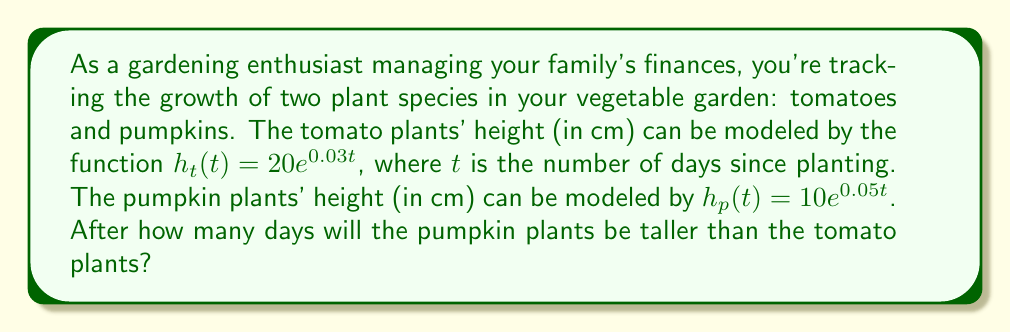Provide a solution to this math problem. To solve this problem, we need to find the point where the heights of the two plants are equal, and then determine when the pumpkin plants become taller. Let's follow these steps:

1) Set up an equation where the heights are equal:
   $$ 20e^{0.03t} = 10e^{0.05t} $$

2) Divide both sides by 10:
   $$ 2e^{0.03t} = e^{0.05t} $$

3) Take the natural logarithm of both sides:
   $$ \ln(2) + 0.03t = 0.05t $$

4) Subtract 0.03t from both sides:
   $$ \ln(2) = 0.02t $$

5) Divide both sides by 0.02:
   $$ t = \frac{\ln(2)}{0.02} \approx 34.66 $$

6) Since we're dealing with whole days, we need to round up to the next integer. The pumpkin plants will be taller than the tomato plants starting on day 35.

To verify:
On day 34: 
Tomatoes: $20e^{0.03(34)} \approx 60.96$ cm
Pumpkins: $10e^{0.05(34)} \approx 60.34$ cm

On day 35:
Tomatoes: $20e^{0.03(35)} \approx 62.80$ cm
Pumpkins: $10e^{0.05(35)} \approx 63.43$ cm
Answer: 35 days 